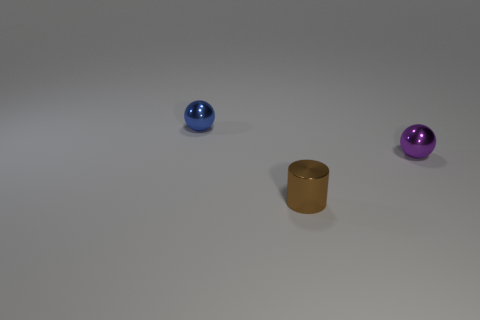Add 3 purple cubes. How many objects exist? 6 Subtract all balls. How many objects are left? 1 Subtract 0 gray cylinders. How many objects are left? 3 Subtract all purple objects. Subtract all brown objects. How many objects are left? 1 Add 2 small purple metal spheres. How many small purple metal spheres are left? 3 Add 1 purple objects. How many purple objects exist? 2 